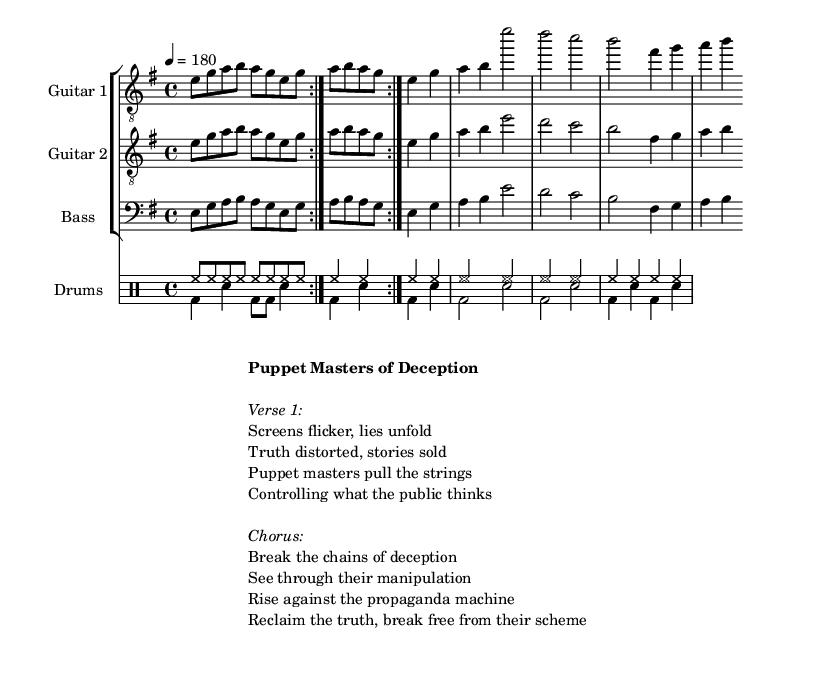What is the key signature of this music? The key signature is indicated by the number of sharps or flats at the beginning of the staff. In this piece, it shows one sharp, which corresponds to E minor.
Answer: E minor What is the time signature of this music? The time signature is indicated in the sheet music, typically presented as a fraction. This piece displays a 4/4 time signature, showing there are four beats per measure.
Answer: 4/4 What is the tempo marking for this piece? The tempo is indicated in beats per minute, shown at the beginning of the score. Here, the tempo marking is 180, meaning the piece should be played at a fast pace.
Answer: 180 How many measures are indicated in one repetition of the volta? The repeat section denoted by the volta indicates how many measures will be repeated. Each repeated section contains four measures before continuing on.
Answer: 4 What lyrics are associated with the chorus of the song? The chorus lyrics are provided in the markup section under the "Chorus" label, which outlines the main message of the song. These lyrics highlight breaking free from deception.
Answer: Break the chains of deception Which musical styles are predominantly featured in this sheet music? The instrumentation and structure, like distorted guitars and heavy drumming, suggest that this music utilizes elements typical of thrash metal. This genre is marked by aggressive rhythms and themes.
Answer: Thrash metal What instruments are part of the ensemble? The score lists specific instruments at the beginning of each staff. The ensemble includes two guitars, bass, and drums, all integral to creating the metal sound.
Answer: Guitar 1, Guitar 2, Bass, Drums 